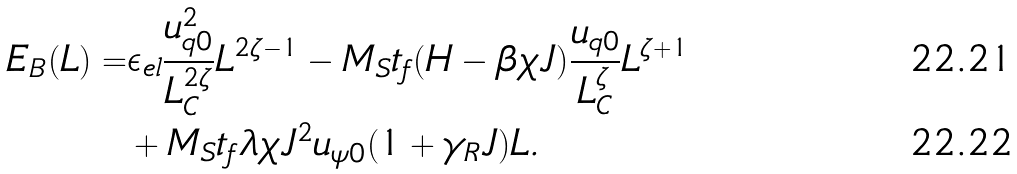Convert formula to latex. <formula><loc_0><loc_0><loc_500><loc_500>E _ { B } ( L ) = & \epsilon _ { e l } \frac { u _ { q 0 } ^ { 2 } } { L _ { C } ^ { 2 \zeta } } L ^ { 2 \zeta - 1 } - M _ { S } t _ { f } ( H - \beta \chi J ) \frac { u _ { q 0 } } { L _ { C } ^ { \zeta } } L ^ { \zeta + 1 } \\ & + M _ { S } t _ { f } \lambda \chi J ^ { 2 } u _ { \psi 0 } ( 1 + \gamma _ { R } J ) L .</formula> 